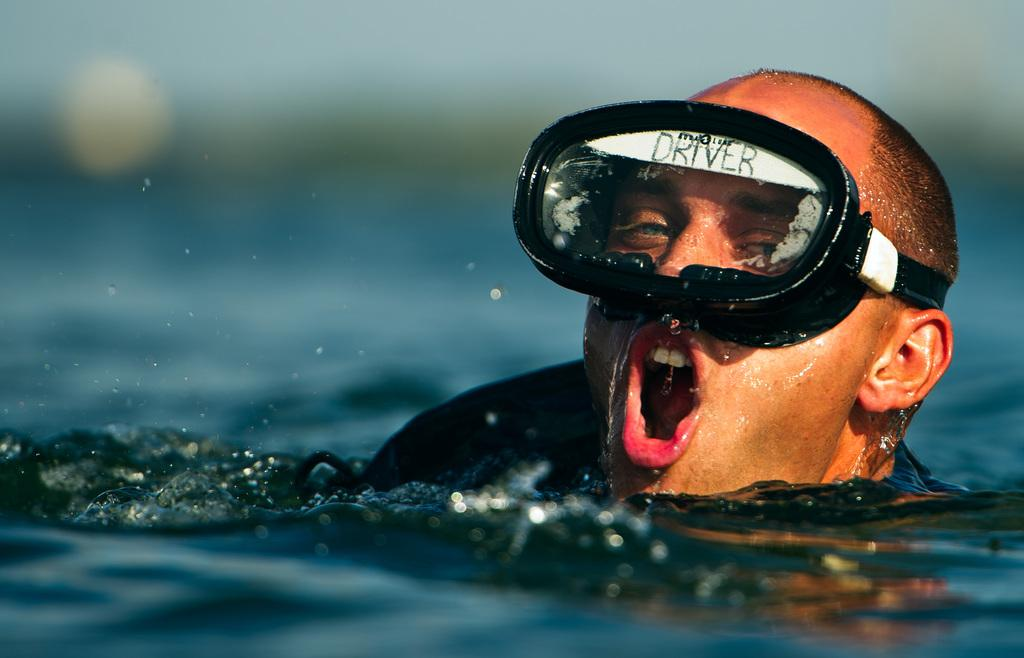Who is the main subject in the image? There is a man in the image. What is the man doing in the image? The man is swimming in the water. Can you describe the background of the image? The background of the image is blurred. What type of degree does the man have in the image? There is no information about the man's degree in the image. How many chairs are visible in the image? There are no chairs present in the image. 